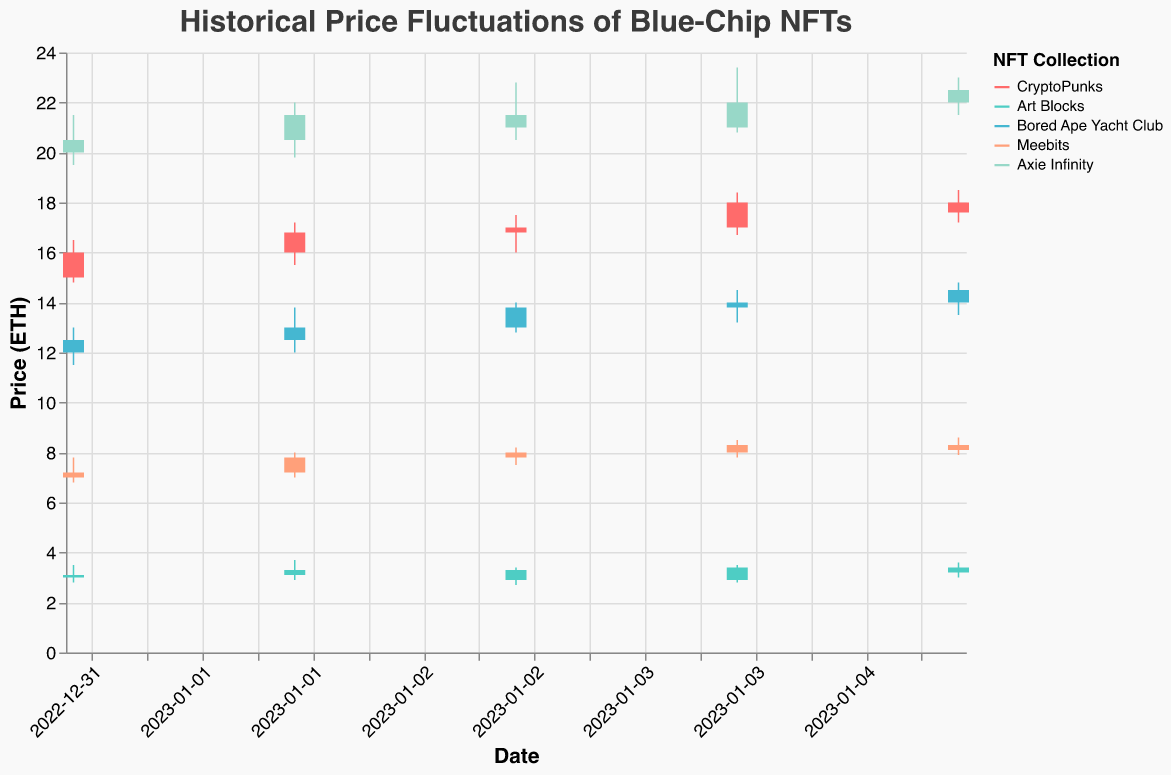How many NFT collections are visualized in the figure? The figure's legend shows different colors representing the NFT collections. By counting the unique entries in the legend, we can see that there are five collections: CryptoPunks, Art Blocks, Bored Ape Yacht Club, Meebits, and Axie Infinity.
Answer: 5 Which NFT collection has the highest closing price on January 4th? By looking at the closing prices on January 4th in the candlestick plot, we can compare the final prices of each collection. The collection Axie Infinity closes at the price of 22.0, which is the highest among all on that date.
Answer: Axie Infinity What is the average closing price of Meebits over the period shown? We calculate the average by summing the closing prices of Meebits over the five dates and dividing by the number of days: (7.2 + 7.8 + 8.0 + 8.3 + 8.1) / 5 = 39.4 / 5 = 7.88.
Answer: 7.88 Between CryptoPunks and Art Blocks, which experienced a higher price volatility on January 5th? Price volatility within a day can be examined by the difference between the high and low prices. For January 5th, CryptoPunks had (18.5 - 17.2) = 1.3 and Art Blocks had (3.6 - 3.0) = 0.6. Thus, CryptoPunks experienced higher volatility.
Answer: CryptoPunks What was the overall trend for the closing price of Bored Ape Yacht Club from January 1st to January 5th? Examining the closing prices for Bored Ape Yacht Club, we see the trend: 12.5, 13.0, 13.8, 14.0, 14.5. This shows a consistent increasing trend over the period.
Answer: Increasing Which NFT collection experienced a dip in its closing price on January 3rd compared to January 2nd? By comparing the closing prices on January 2nd and January 3rd, we observe the values. CryptoPunks increased from 16.8 to 17.0. Art Blocks decreased from 3.3 to 2.9. Bored Ape Yacht Club increased from 13.0 to 13.8. Meebits increased from 7.8 to 8.0. Axie Infinity decreased from 21.5 to 21.0. Hence, Art Blocks and Axie Infinity experienced dips.
Answer: Art Blocks, Axie Infinity Among all the NFT collections, which one had the highest opening price on January 2nd? The opening prices on January 2nd for each NFT collection are: CryptoPunks (16.0), Art Blocks (3.1), Bored Ape Yacht Club (12.5), Meebits (7.2), Axie Infinity (20.5). The collection Axie Infinity has the highest opening price of 20.5.
Answer: Axie Infinity How does the candlestick representation help in understanding the price fluctuations better compared to a simple line chart? The candlestick representation shows multiple key price points (open, high, low, close) for each time period, whereas a simple line chart would typically only show a single point (close price). This helps in understanding the intraday volatility and price movement patterns more comprehensively.
Answer: It provides detailed price points If you were to calculate the range of closing prices for CryptoPunks during the first five days of January, what would it be? The range is calculated by subtracting the lowest closing price from the highest closing price during the period. For CryptoPunks, the closing prices are: 16.0, 16.8, 17.0, 18.0, 17.6. The highest closing price is 18.0 and the lowest is 16.0. Therefore, the range is 18.0 - 16.0 = 2.0.
Answer: 2.0 